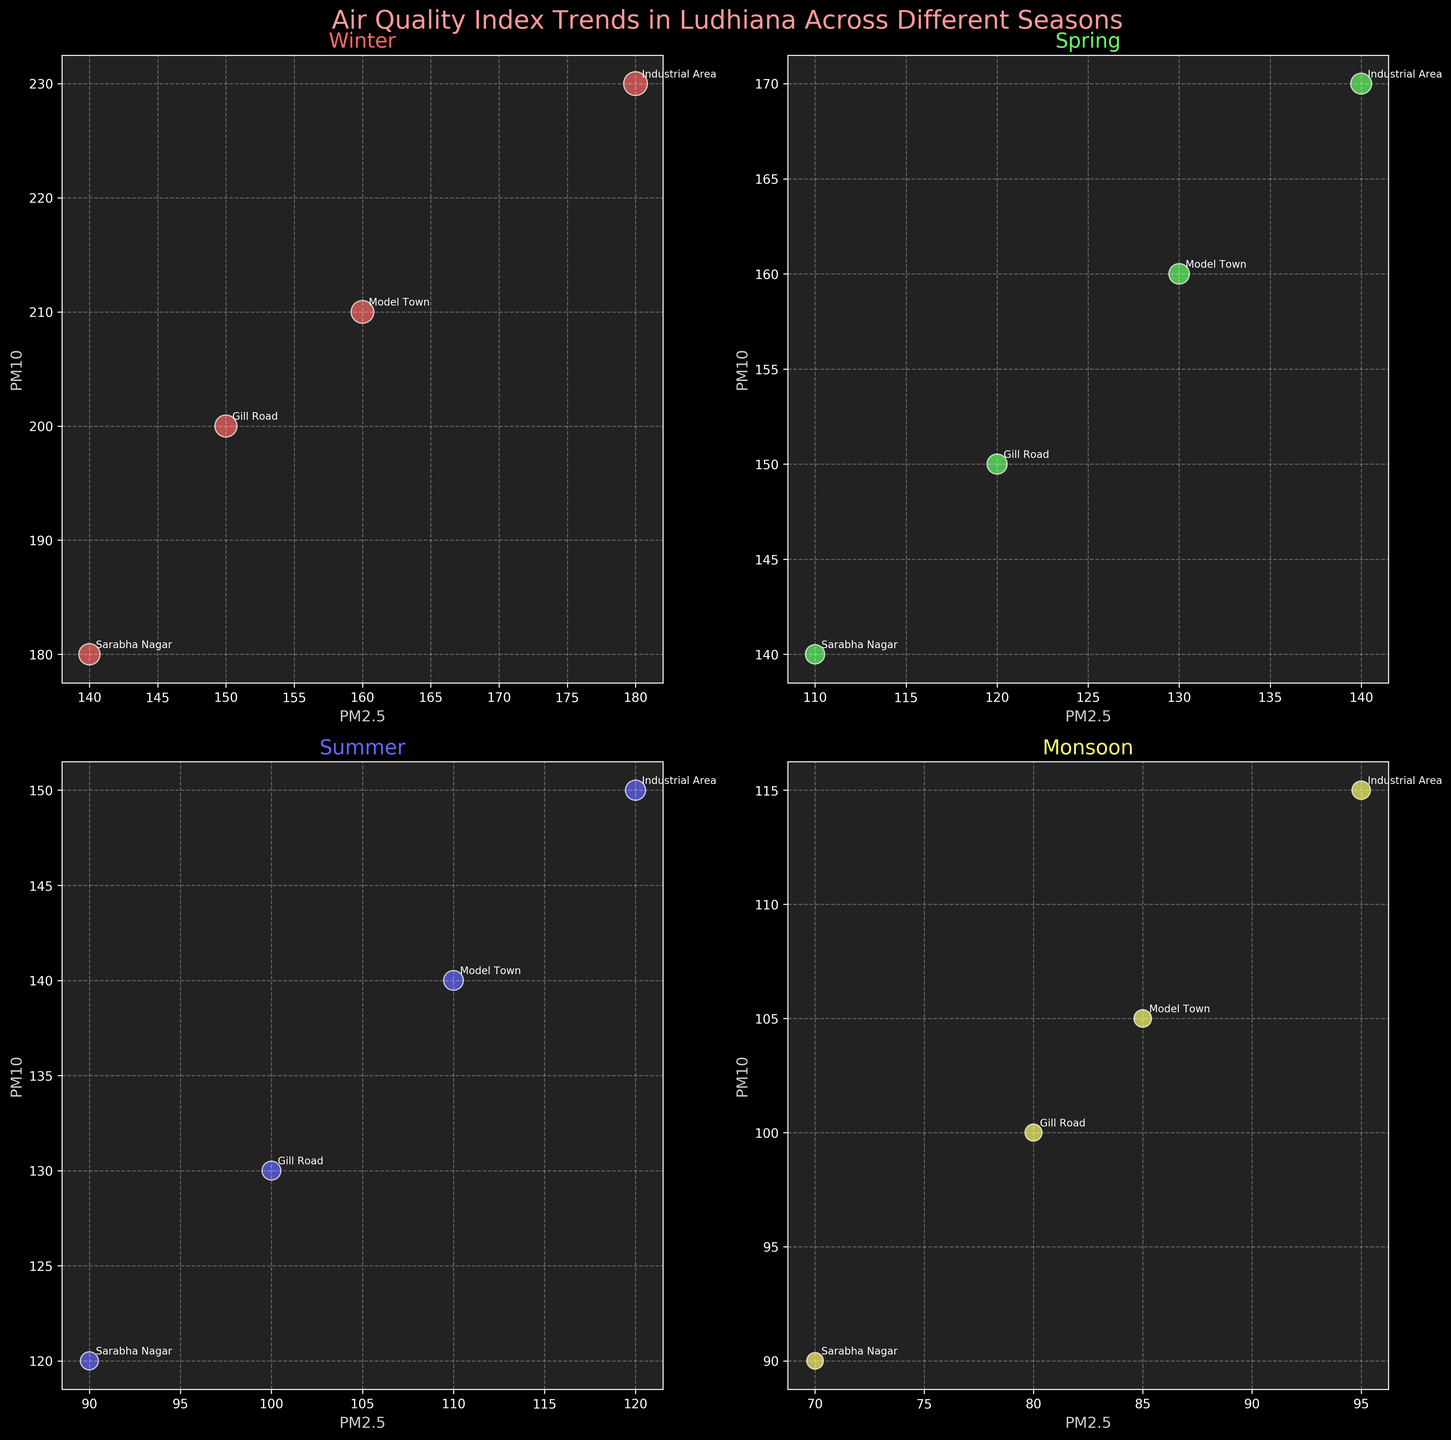What's the title of the figure? The title is usually found at the top of the plot and provides a brief summary of what the figure is about. In this case, it reads, "Air Quality Index Trends in Ludhiana Across Different Seasons."
Answer: Air Quality Index Trends in Ludhiana Across Different Seasons How are the seasons distinguished in the figure? The seasons are distinguished by assigning different colors to each season. These colors help visually separate the data for Winter, Spring, Summer, and Monsoon.
Answer: By colors What are the axes labels in the subplots? The x-axis is labeled "PM2.5," and the y-axis is labeled "PM10" in each subplot. These labels indicate the variables being plotted.
Answer: PM2.5 and PM10 Which season has the highest PM2.5 value and which location is it from? Look at the subplot for each season and identify the highest point on the x-axis (PM2.5). The highest value is in the Winter season from the Industrial Area location (PM2.5: 180).
Answer: Winter, Industrial Area Comparing all locations, which season generally shows the lowest PM2.5 and PM10 levels? Inspect each subplot and look for the general trend. Summer and Monsoon show lower values, but Monsoon generally has the lowest PM2.5 and PM10 levels overall.
Answer: Monsoon In which season does Sarabha Nagar have the highest bubble size, and what does the bubble size represent? By observing the size of the bubbles for Sarabha Nagar in different subplots, it is evident that the largest bubble size for Sarabha Nagar occurs in Winter. The bubble size represents the value corresponding to Air Quality-related metrics.
Answer: Winter How does the correlation between PM2.5 and PM10 vary across the seasons? Observe the direction and concentration of the points in each subplot. In all seasons, it's clear that there's a positive correlation between PM2.5 and PM10, but Winter exhibits a steeper upward trend compared to other seasons.
Answer: Positive correlation, steeper in Winter What is the range of PM2.5 values observed in the Industrial Area during Spring? Look at the Spring subplot and identify the minimum and maximum PM2.5 values for the Industrial Area. The range is from 140 to 170.
Answer: 140 to 170 Which season has the smallest bubble size for Model Town, and what could this signify? By observing the size of the bubbles for Model Town across the subplots, the smallest bubble size is seen in the Monsoon season. This signifies lower AQI values for this location during Monsoon.
Answer: Monsoon 